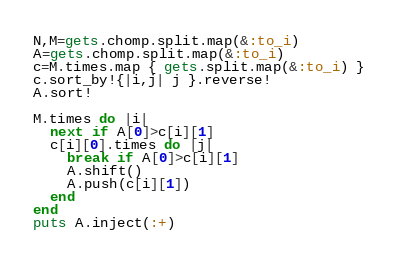Convert code to text. <code><loc_0><loc_0><loc_500><loc_500><_Ruby_>N,M=gets.chomp.split.map(&:to_i)
A=gets.chomp.split.map(&:to_i)
c=M.times.map { gets.split.map(&:to_i) }
c.sort_by!{|i,j| j }.reverse!
A.sort!

M.times do |i|
  next if A[0]>c[i][1]
  c[i][0].times do |j|
    break if A[0]>c[i][1]
    A.shift()
    A.push(c[i][1])
  end
end
puts A.inject(:+)
</code> 